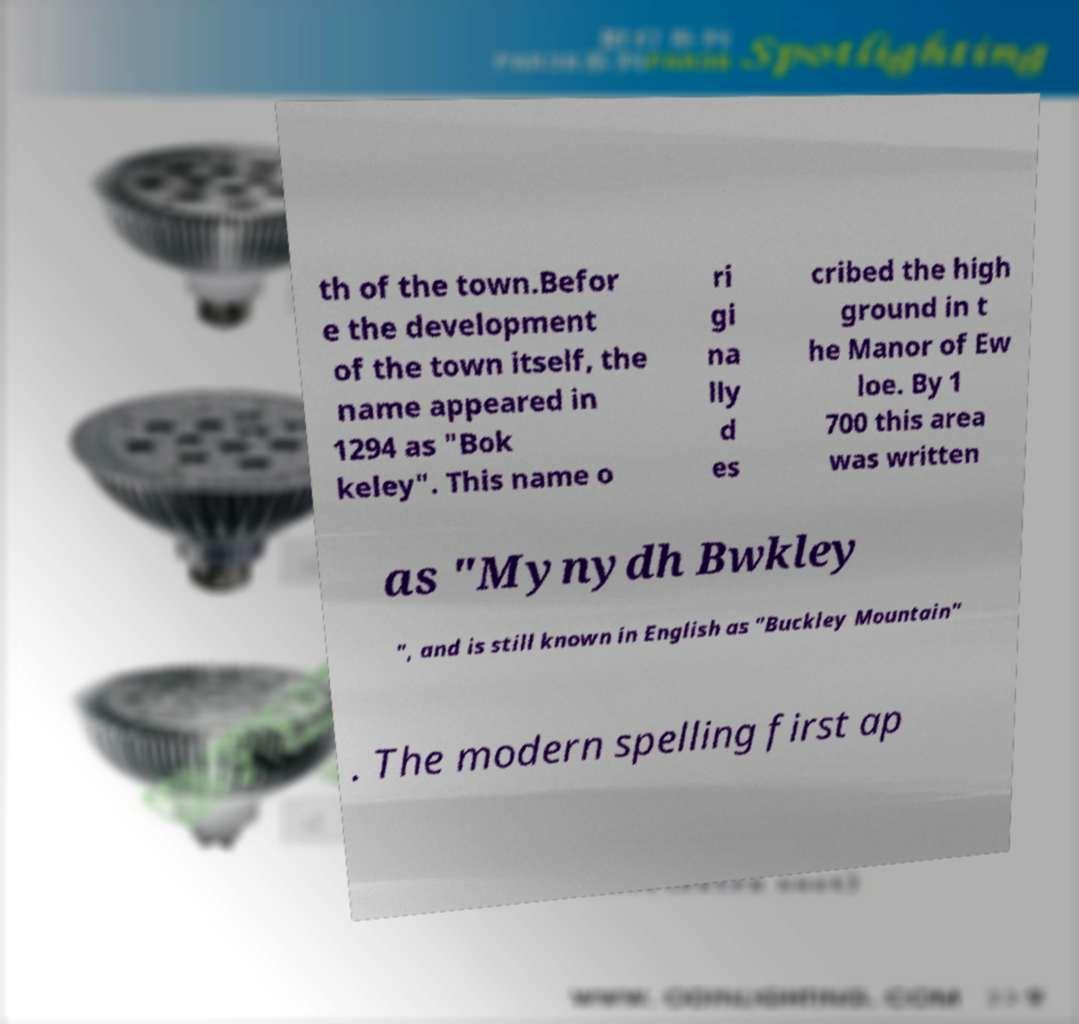I need the written content from this picture converted into text. Can you do that? th of the town.Befor e the development of the town itself, the name appeared in 1294 as "Bok keley". This name o ri gi na lly d es cribed the high ground in t he Manor of Ew loe. By 1 700 this area was written as "Mynydh Bwkley ", and is still known in English as "Buckley Mountain" . The modern spelling first ap 